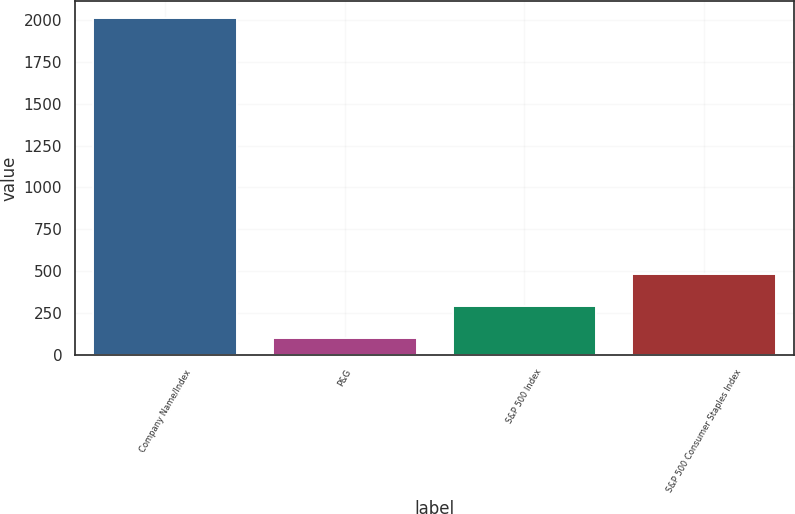Convert chart. <chart><loc_0><loc_0><loc_500><loc_500><bar_chart><fcel>Company Name/Index<fcel>P&G<fcel>S&P 500 Index<fcel>S&P 500 Consumer Staples Index<nl><fcel>2011<fcel>100<fcel>291.1<fcel>482.2<nl></chart> 